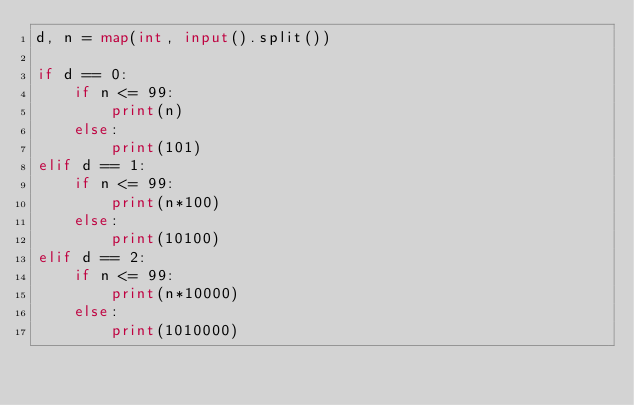Convert code to text. <code><loc_0><loc_0><loc_500><loc_500><_Python_>d, n = map(int, input().split())

if d == 0:
    if n <= 99:
        print(n)
    else:
        print(101)
elif d == 1:
    if n <= 99:
        print(n*100)
    else:
        print(10100)
elif d == 2:
    if n <= 99:
        print(n*10000)
    else:
        print(1010000)</code> 